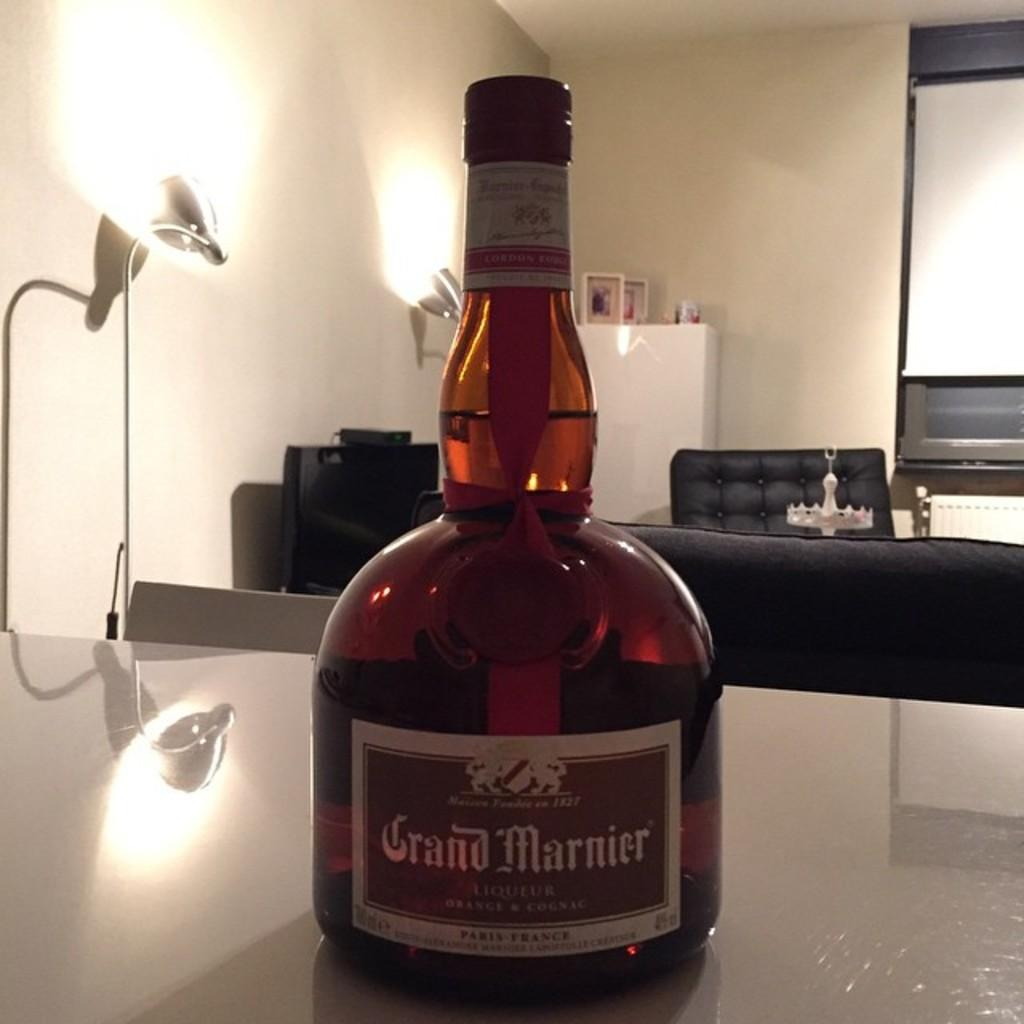Provide a one-sentence caption for the provided image. Bottle of Grand Marnier liquor on a table. 